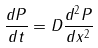<formula> <loc_0><loc_0><loc_500><loc_500>\frac { d P } { d t } = D \frac { d ^ { 2 } P } { d x ^ { 2 } }</formula> 